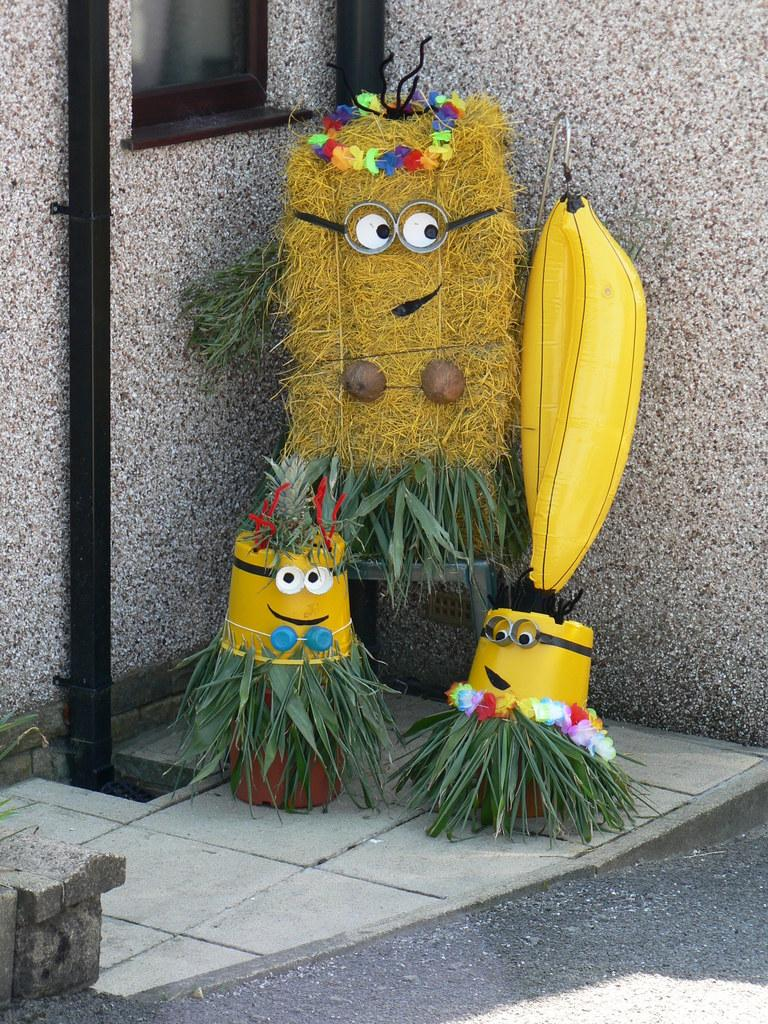What color are the leaves in the image? The leaves in the image are green. What color are the other objects in the image besides the leaves? There are yellow color things in the image. What type of object is black and visible in the image? There is a black pipe in the image. What feature allows for a view of the outside in the image? There is a window in the image. What can be described as having various colors in the image? There are colorful things visible in the image. What type of mist can be seen coming from the yellow things in the image? There is no mist present in the image; it only features green leaves, yellow things, a black pipe, a window, and colorful objects. What songs are being sung by the green leaves in the image? The green leaves in the image are not capable of singing songs, as they are inanimate objects. --- Facts: 1. There is a person sitting on a chair in the image. 2. The person is holding a book. 3. There is a table next to the person. 4. There is a cup on the table. 5. There is a plant on the table. Absurd Topics: lion Conversation: What is the main subject in the image? There is a person sitting on a chair in the image. What is the person holding? The person is holding a book. What is next to the person? There is a table next to the person. What can be found on the table? There is a cup on the table. What else is on the table? There is a plant on the table. Reasoning: Let's think step by step in order to produce the conversation. We start by identifying the main subject of the image, which is the person sitting on a chair. Next, we describe what the person is holding, which is a book. Then, we observe what is next to the person, which is a table. After that, we focus on the objects found on the table, which are a cup and a plant. Absurd Question/Answer: What type of lion can be seen in the image? There is no lion present in the image. 